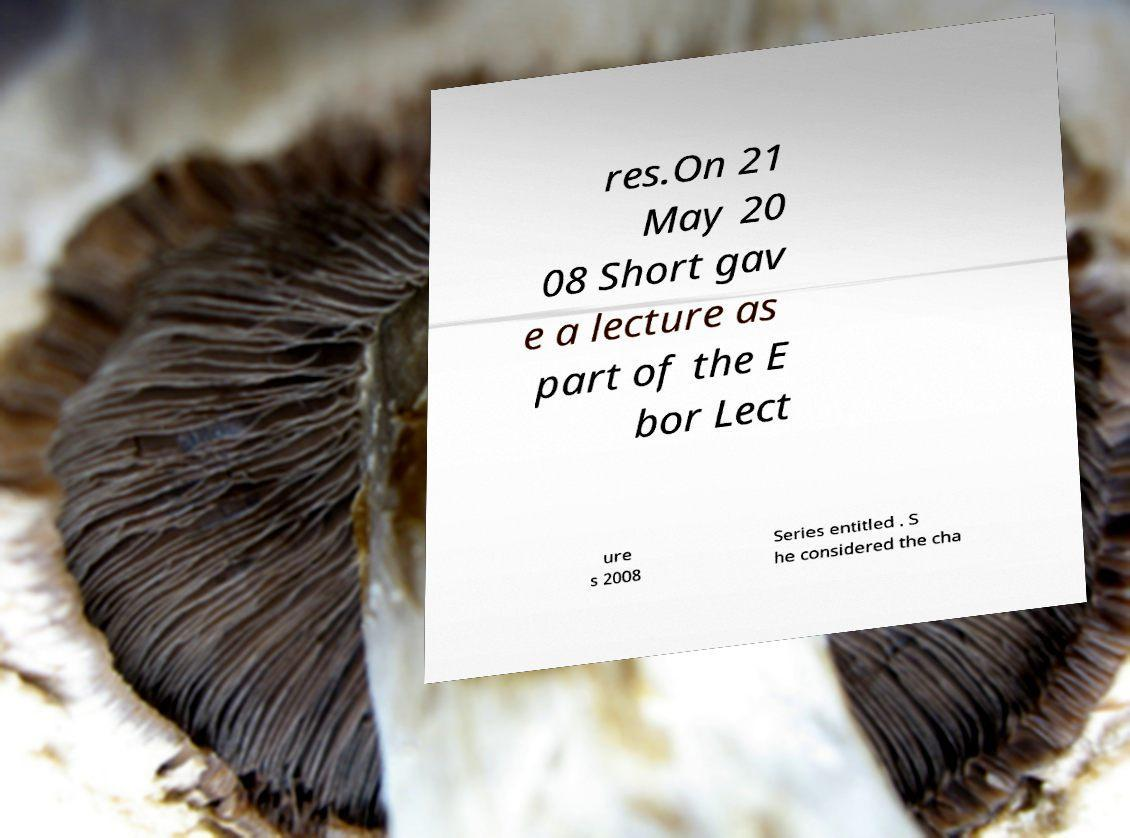Can you read and provide the text displayed in the image?This photo seems to have some interesting text. Can you extract and type it out for me? res.On 21 May 20 08 Short gav e a lecture as part of the E bor Lect ure s 2008 Series entitled . S he considered the cha 